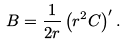Convert formula to latex. <formula><loc_0><loc_0><loc_500><loc_500>B = \frac { 1 } { 2 r } \left ( r ^ { 2 } C \right ) ^ { \prime } .</formula> 